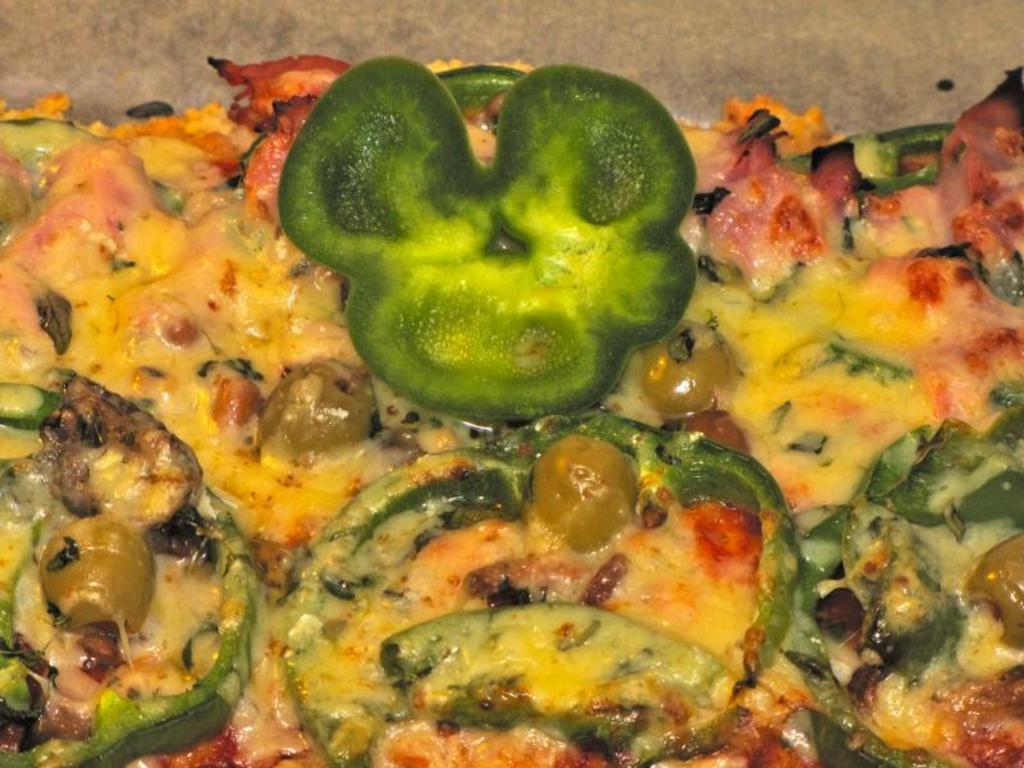What is the main subject of the image? There is a food item in the image. What type of ingredient can be seen in the food item? The food item contains pieces of capsicum. Are there any other ingredients or components in the food item? Yes, there are other items present in the food item. How many feet can be seen in the image? There are no feet visible in the image. Is there a girl holding the food item in the image? The image does not show a girl or anyone holding the food item. 